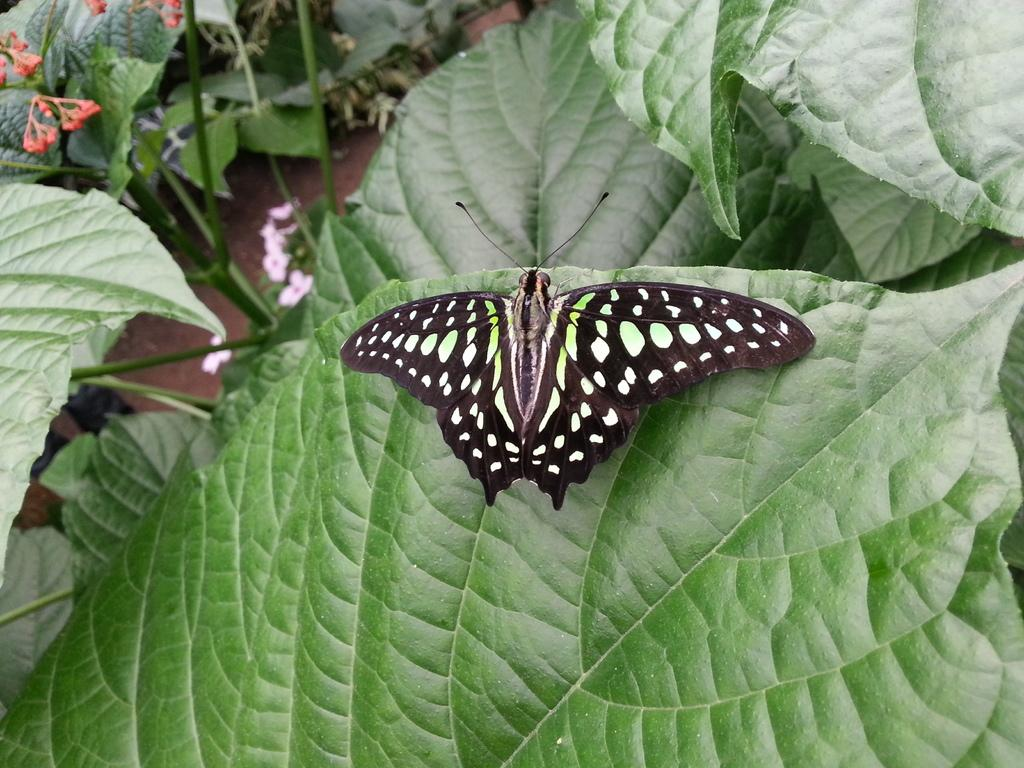What is the main subject of the image? There is a butterfly in the image. Where is the butterfly located? The butterfly is on a leaf. What else can be seen in the image besides the butterfly? There are plants in the image. What type of elbow can be seen in the image? There is no elbow present in the image; it features a butterfly on a leaf and plants. 